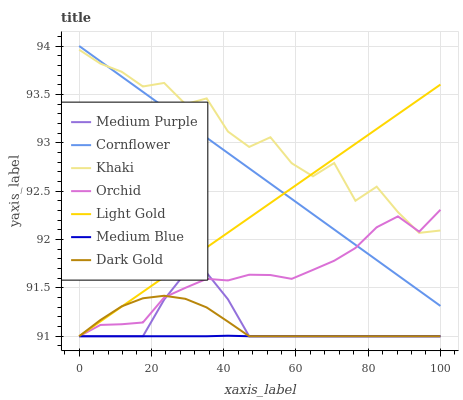Does Medium Blue have the minimum area under the curve?
Answer yes or no. Yes. Does Khaki have the maximum area under the curve?
Answer yes or no. Yes. Does Dark Gold have the minimum area under the curve?
Answer yes or no. No. Does Dark Gold have the maximum area under the curve?
Answer yes or no. No. Is Light Gold the smoothest?
Answer yes or no. Yes. Is Khaki the roughest?
Answer yes or no. Yes. Is Dark Gold the smoothest?
Answer yes or no. No. Is Dark Gold the roughest?
Answer yes or no. No. Does Dark Gold have the lowest value?
Answer yes or no. Yes. Does Khaki have the lowest value?
Answer yes or no. No. Does Cornflower have the highest value?
Answer yes or no. Yes. Does Khaki have the highest value?
Answer yes or no. No. Is Dark Gold less than Cornflower?
Answer yes or no. Yes. Is Khaki greater than Medium Purple?
Answer yes or no. Yes. Does Light Gold intersect Medium Purple?
Answer yes or no. Yes. Is Light Gold less than Medium Purple?
Answer yes or no. No. Is Light Gold greater than Medium Purple?
Answer yes or no. No. Does Dark Gold intersect Cornflower?
Answer yes or no. No. 